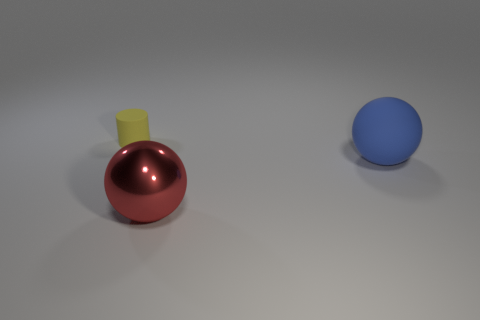Is there any other thing that is the same size as the cylinder?
Provide a succinct answer. No. There is a object that is both behind the large red shiny sphere and to the left of the blue object; what is its color?
Offer a very short reply. Yellow. There is a blue matte thing that is the same size as the shiny sphere; what shape is it?
Your answer should be compact. Sphere. Are there any big blue matte things of the same shape as the big metal object?
Your answer should be compact. Yes. There is a object that is in front of the blue rubber thing; does it have the same size as the blue matte sphere?
Make the answer very short. Yes. There is a object that is left of the big blue rubber object and on the right side of the yellow matte cylinder; what size is it?
Your answer should be compact. Large. What number of other things are there of the same material as the large red ball
Provide a succinct answer. 0. What is the size of the matte thing that is on the right side of the tiny yellow matte cylinder?
Provide a succinct answer. Large. How many large objects are yellow blocks or cylinders?
Keep it short and to the point. 0. There is a blue matte object; are there any metal spheres left of it?
Your answer should be compact. Yes. 